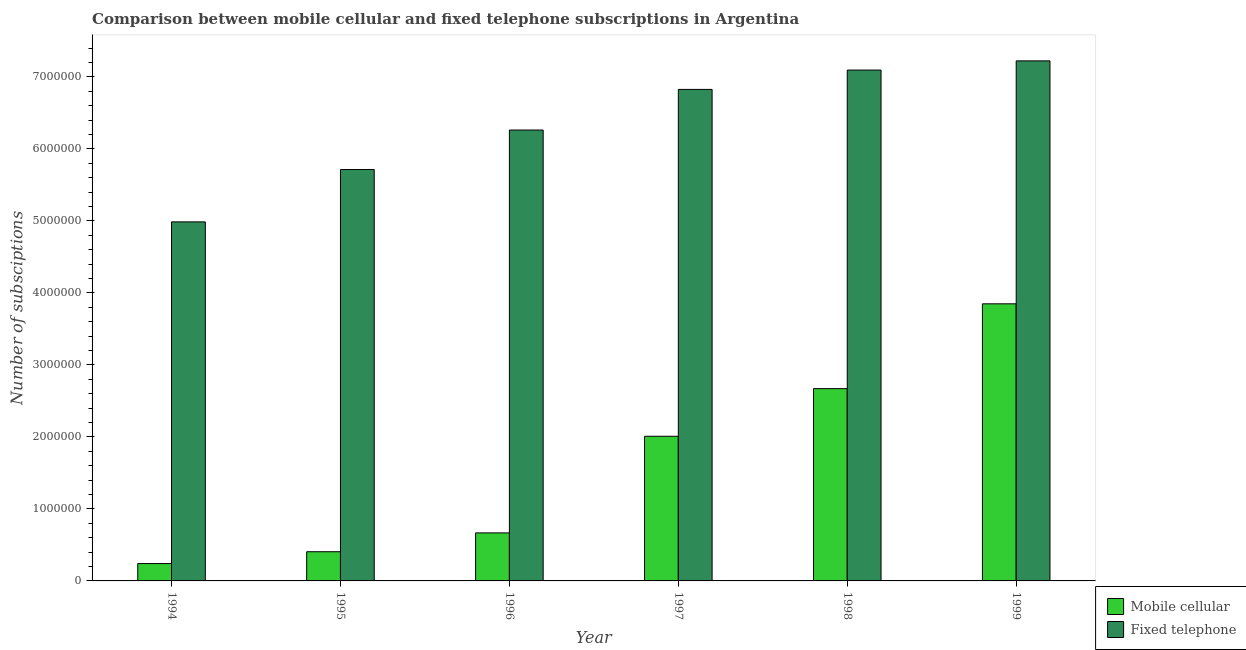How many different coloured bars are there?
Your response must be concise. 2. Are the number of bars per tick equal to the number of legend labels?
Your answer should be very brief. Yes. How many bars are there on the 5th tick from the left?
Offer a very short reply. 2. How many bars are there on the 4th tick from the right?
Your answer should be very brief. 2. In how many cases, is the number of bars for a given year not equal to the number of legend labels?
Your response must be concise. 0. What is the number of fixed telephone subscriptions in 1994?
Your answer should be compact. 4.99e+06. Across all years, what is the maximum number of mobile cellular subscriptions?
Keep it short and to the point. 3.85e+06. Across all years, what is the minimum number of mobile cellular subscriptions?
Keep it short and to the point. 2.41e+05. What is the total number of fixed telephone subscriptions in the graph?
Ensure brevity in your answer.  3.81e+07. What is the difference between the number of mobile cellular subscriptions in 1994 and that in 1999?
Give a very brief answer. -3.61e+06. What is the difference between the number of mobile cellular subscriptions in 1997 and the number of fixed telephone subscriptions in 1998?
Offer a very short reply. -6.62e+05. What is the average number of fixed telephone subscriptions per year?
Offer a terse response. 6.35e+06. In the year 1996, what is the difference between the number of mobile cellular subscriptions and number of fixed telephone subscriptions?
Give a very brief answer. 0. What is the ratio of the number of fixed telephone subscriptions in 1995 to that in 1996?
Offer a very short reply. 0.91. Is the difference between the number of fixed telephone subscriptions in 1995 and 1998 greater than the difference between the number of mobile cellular subscriptions in 1995 and 1998?
Offer a very short reply. No. What is the difference between the highest and the second highest number of fixed telephone subscriptions?
Provide a succinct answer. 1.28e+05. What is the difference between the highest and the lowest number of mobile cellular subscriptions?
Give a very brief answer. 3.61e+06. What does the 1st bar from the left in 1996 represents?
Give a very brief answer. Mobile cellular. What does the 2nd bar from the right in 1995 represents?
Offer a terse response. Mobile cellular. How many years are there in the graph?
Your answer should be compact. 6. Are the values on the major ticks of Y-axis written in scientific E-notation?
Make the answer very short. No. Does the graph contain any zero values?
Provide a short and direct response. No. Where does the legend appear in the graph?
Provide a succinct answer. Bottom right. How many legend labels are there?
Ensure brevity in your answer.  2. What is the title of the graph?
Provide a short and direct response. Comparison between mobile cellular and fixed telephone subscriptions in Argentina. Does "Malaria" appear as one of the legend labels in the graph?
Your answer should be very brief. No. What is the label or title of the Y-axis?
Provide a succinct answer. Number of subsciptions. What is the Number of subsciptions in Mobile cellular in 1994?
Provide a short and direct response. 2.41e+05. What is the Number of subsciptions of Fixed telephone in 1994?
Make the answer very short. 4.99e+06. What is the Number of subsciptions of Mobile cellular in 1995?
Give a very brief answer. 4.05e+05. What is the Number of subsciptions of Fixed telephone in 1995?
Provide a short and direct response. 5.71e+06. What is the Number of subsciptions in Mobile cellular in 1996?
Offer a very short reply. 6.67e+05. What is the Number of subsciptions of Fixed telephone in 1996?
Make the answer very short. 6.26e+06. What is the Number of subsciptions in Mobile cellular in 1997?
Offer a very short reply. 2.01e+06. What is the Number of subsciptions in Fixed telephone in 1997?
Ensure brevity in your answer.  6.83e+06. What is the Number of subsciptions of Mobile cellular in 1998?
Your answer should be compact. 2.67e+06. What is the Number of subsciptions in Fixed telephone in 1998?
Give a very brief answer. 7.10e+06. What is the Number of subsciptions of Mobile cellular in 1999?
Your response must be concise. 3.85e+06. What is the Number of subsciptions in Fixed telephone in 1999?
Provide a succinct answer. 7.22e+06. Across all years, what is the maximum Number of subsciptions of Mobile cellular?
Offer a terse response. 3.85e+06. Across all years, what is the maximum Number of subsciptions in Fixed telephone?
Provide a succinct answer. 7.22e+06. Across all years, what is the minimum Number of subsciptions in Mobile cellular?
Offer a very short reply. 2.41e+05. Across all years, what is the minimum Number of subsciptions in Fixed telephone?
Keep it short and to the point. 4.99e+06. What is the total Number of subsciptions of Mobile cellular in the graph?
Keep it short and to the point. 9.84e+06. What is the total Number of subsciptions in Fixed telephone in the graph?
Provide a short and direct response. 3.81e+07. What is the difference between the Number of subsciptions in Mobile cellular in 1994 and that in 1995?
Keep it short and to the point. -1.64e+05. What is the difference between the Number of subsciptions in Fixed telephone in 1994 and that in 1995?
Provide a succinct answer. -7.27e+05. What is the difference between the Number of subsciptions in Mobile cellular in 1994 and that in 1996?
Provide a succinct answer. -4.26e+05. What is the difference between the Number of subsciptions in Fixed telephone in 1994 and that in 1996?
Your response must be concise. -1.28e+06. What is the difference between the Number of subsciptions of Mobile cellular in 1994 and that in 1997?
Provide a succinct answer. -1.77e+06. What is the difference between the Number of subsciptions of Fixed telephone in 1994 and that in 1997?
Provide a short and direct response. -1.84e+06. What is the difference between the Number of subsciptions of Mobile cellular in 1994 and that in 1998?
Make the answer very short. -2.43e+06. What is the difference between the Number of subsciptions in Fixed telephone in 1994 and that in 1998?
Give a very brief answer. -2.11e+06. What is the difference between the Number of subsciptions of Mobile cellular in 1994 and that in 1999?
Your response must be concise. -3.61e+06. What is the difference between the Number of subsciptions of Fixed telephone in 1994 and that in 1999?
Your answer should be very brief. -2.24e+06. What is the difference between the Number of subsciptions in Mobile cellular in 1995 and that in 1996?
Make the answer very short. -2.62e+05. What is the difference between the Number of subsciptions in Fixed telephone in 1995 and that in 1996?
Provide a succinct answer. -5.48e+05. What is the difference between the Number of subsciptions in Mobile cellular in 1995 and that in 1997?
Provide a short and direct response. -1.60e+06. What is the difference between the Number of subsciptions of Fixed telephone in 1995 and that in 1997?
Provide a short and direct response. -1.11e+06. What is the difference between the Number of subsciptions in Mobile cellular in 1995 and that in 1998?
Your answer should be very brief. -2.27e+06. What is the difference between the Number of subsciptions of Fixed telephone in 1995 and that in 1998?
Ensure brevity in your answer.  -1.38e+06. What is the difference between the Number of subsciptions in Mobile cellular in 1995 and that in 1999?
Your answer should be compact. -3.44e+06. What is the difference between the Number of subsciptions of Fixed telephone in 1995 and that in 1999?
Make the answer very short. -1.51e+06. What is the difference between the Number of subsciptions of Mobile cellular in 1996 and that in 1997?
Provide a short and direct response. -1.34e+06. What is the difference between the Number of subsciptions in Fixed telephone in 1996 and that in 1997?
Offer a terse response. -5.64e+05. What is the difference between the Number of subsciptions of Mobile cellular in 1996 and that in 1998?
Keep it short and to the point. -2.00e+06. What is the difference between the Number of subsciptions of Fixed telephone in 1996 and that in 1998?
Offer a terse response. -8.33e+05. What is the difference between the Number of subsciptions of Mobile cellular in 1996 and that in 1999?
Provide a succinct answer. -3.18e+06. What is the difference between the Number of subsciptions of Fixed telephone in 1996 and that in 1999?
Give a very brief answer. -9.61e+05. What is the difference between the Number of subsciptions of Mobile cellular in 1997 and that in 1998?
Give a very brief answer. -6.62e+05. What is the difference between the Number of subsciptions of Fixed telephone in 1997 and that in 1998?
Give a very brief answer. -2.69e+05. What is the difference between the Number of subsciptions in Mobile cellular in 1997 and that in 1999?
Ensure brevity in your answer.  -1.84e+06. What is the difference between the Number of subsciptions in Fixed telephone in 1997 and that in 1999?
Offer a very short reply. -3.96e+05. What is the difference between the Number of subsciptions of Mobile cellular in 1998 and that in 1999?
Your answer should be compact. -1.18e+06. What is the difference between the Number of subsciptions of Fixed telephone in 1998 and that in 1999?
Provide a succinct answer. -1.28e+05. What is the difference between the Number of subsciptions of Mobile cellular in 1994 and the Number of subsciptions of Fixed telephone in 1995?
Keep it short and to the point. -5.47e+06. What is the difference between the Number of subsciptions of Mobile cellular in 1994 and the Number of subsciptions of Fixed telephone in 1996?
Give a very brief answer. -6.02e+06. What is the difference between the Number of subsciptions of Mobile cellular in 1994 and the Number of subsciptions of Fixed telephone in 1997?
Your answer should be compact. -6.59e+06. What is the difference between the Number of subsciptions in Mobile cellular in 1994 and the Number of subsciptions in Fixed telephone in 1998?
Keep it short and to the point. -6.85e+06. What is the difference between the Number of subsciptions of Mobile cellular in 1994 and the Number of subsciptions of Fixed telephone in 1999?
Ensure brevity in your answer.  -6.98e+06. What is the difference between the Number of subsciptions in Mobile cellular in 1995 and the Number of subsciptions in Fixed telephone in 1996?
Provide a succinct answer. -5.86e+06. What is the difference between the Number of subsciptions in Mobile cellular in 1995 and the Number of subsciptions in Fixed telephone in 1997?
Offer a terse response. -6.42e+06. What is the difference between the Number of subsciptions in Mobile cellular in 1995 and the Number of subsciptions in Fixed telephone in 1998?
Your response must be concise. -6.69e+06. What is the difference between the Number of subsciptions in Mobile cellular in 1995 and the Number of subsciptions in Fixed telephone in 1999?
Ensure brevity in your answer.  -6.82e+06. What is the difference between the Number of subsciptions of Mobile cellular in 1996 and the Number of subsciptions of Fixed telephone in 1997?
Give a very brief answer. -6.16e+06. What is the difference between the Number of subsciptions of Mobile cellular in 1996 and the Number of subsciptions of Fixed telephone in 1998?
Make the answer very short. -6.43e+06. What is the difference between the Number of subsciptions in Mobile cellular in 1996 and the Number of subsciptions in Fixed telephone in 1999?
Your answer should be compact. -6.56e+06. What is the difference between the Number of subsciptions of Mobile cellular in 1997 and the Number of subsciptions of Fixed telephone in 1998?
Give a very brief answer. -5.09e+06. What is the difference between the Number of subsciptions in Mobile cellular in 1997 and the Number of subsciptions in Fixed telephone in 1999?
Offer a very short reply. -5.21e+06. What is the difference between the Number of subsciptions of Mobile cellular in 1998 and the Number of subsciptions of Fixed telephone in 1999?
Keep it short and to the point. -4.55e+06. What is the average Number of subsciptions in Mobile cellular per year?
Your answer should be very brief. 1.64e+06. What is the average Number of subsciptions of Fixed telephone per year?
Make the answer very short. 6.35e+06. In the year 1994, what is the difference between the Number of subsciptions in Mobile cellular and Number of subsciptions in Fixed telephone?
Give a very brief answer. -4.75e+06. In the year 1995, what is the difference between the Number of subsciptions in Mobile cellular and Number of subsciptions in Fixed telephone?
Ensure brevity in your answer.  -5.31e+06. In the year 1996, what is the difference between the Number of subsciptions of Mobile cellular and Number of subsciptions of Fixed telephone?
Provide a short and direct response. -5.60e+06. In the year 1997, what is the difference between the Number of subsciptions of Mobile cellular and Number of subsciptions of Fixed telephone?
Your response must be concise. -4.82e+06. In the year 1998, what is the difference between the Number of subsciptions of Mobile cellular and Number of subsciptions of Fixed telephone?
Offer a terse response. -4.42e+06. In the year 1999, what is the difference between the Number of subsciptions in Mobile cellular and Number of subsciptions in Fixed telephone?
Your response must be concise. -3.37e+06. What is the ratio of the Number of subsciptions in Mobile cellular in 1994 to that in 1995?
Keep it short and to the point. 0.59. What is the ratio of the Number of subsciptions of Fixed telephone in 1994 to that in 1995?
Your response must be concise. 0.87. What is the ratio of the Number of subsciptions in Mobile cellular in 1994 to that in 1996?
Make the answer very short. 0.36. What is the ratio of the Number of subsciptions of Fixed telephone in 1994 to that in 1996?
Your answer should be compact. 0.8. What is the ratio of the Number of subsciptions of Mobile cellular in 1994 to that in 1997?
Make the answer very short. 0.12. What is the ratio of the Number of subsciptions in Fixed telephone in 1994 to that in 1997?
Keep it short and to the point. 0.73. What is the ratio of the Number of subsciptions of Mobile cellular in 1994 to that in 1998?
Provide a succinct answer. 0.09. What is the ratio of the Number of subsciptions of Fixed telephone in 1994 to that in 1998?
Keep it short and to the point. 0.7. What is the ratio of the Number of subsciptions in Mobile cellular in 1994 to that in 1999?
Give a very brief answer. 0.06. What is the ratio of the Number of subsciptions in Fixed telephone in 1994 to that in 1999?
Ensure brevity in your answer.  0.69. What is the ratio of the Number of subsciptions in Mobile cellular in 1995 to that in 1996?
Keep it short and to the point. 0.61. What is the ratio of the Number of subsciptions of Fixed telephone in 1995 to that in 1996?
Your answer should be very brief. 0.91. What is the ratio of the Number of subsciptions of Mobile cellular in 1995 to that in 1997?
Your answer should be compact. 0.2. What is the ratio of the Number of subsciptions in Fixed telephone in 1995 to that in 1997?
Provide a succinct answer. 0.84. What is the ratio of the Number of subsciptions in Mobile cellular in 1995 to that in 1998?
Ensure brevity in your answer.  0.15. What is the ratio of the Number of subsciptions of Fixed telephone in 1995 to that in 1998?
Your response must be concise. 0.81. What is the ratio of the Number of subsciptions of Mobile cellular in 1995 to that in 1999?
Offer a very short reply. 0.11. What is the ratio of the Number of subsciptions in Fixed telephone in 1995 to that in 1999?
Your answer should be very brief. 0.79. What is the ratio of the Number of subsciptions in Mobile cellular in 1996 to that in 1997?
Provide a succinct answer. 0.33. What is the ratio of the Number of subsciptions in Fixed telephone in 1996 to that in 1997?
Give a very brief answer. 0.92. What is the ratio of the Number of subsciptions in Mobile cellular in 1996 to that in 1998?
Give a very brief answer. 0.25. What is the ratio of the Number of subsciptions of Fixed telephone in 1996 to that in 1998?
Your response must be concise. 0.88. What is the ratio of the Number of subsciptions of Mobile cellular in 1996 to that in 1999?
Offer a very short reply. 0.17. What is the ratio of the Number of subsciptions of Fixed telephone in 1996 to that in 1999?
Your response must be concise. 0.87. What is the ratio of the Number of subsciptions of Mobile cellular in 1997 to that in 1998?
Keep it short and to the point. 0.75. What is the ratio of the Number of subsciptions of Fixed telephone in 1997 to that in 1998?
Keep it short and to the point. 0.96. What is the ratio of the Number of subsciptions of Mobile cellular in 1997 to that in 1999?
Offer a very short reply. 0.52. What is the ratio of the Number of subsciptions in Fixed telephone in 1997 to that in 1999?
Your answer should be very brief. 0.95. What is the ratio of the Number of subsciptions of Mobile cellular in 1998 to that in 1999?
Offer a very short reply. 0.69. What is the ratio of the Number of subsciptions in Fixed telephone in 1998 to that in 1999?
Provide a short and direct response. 0.98. What is the difference between the highest and the second highest Number of subsciptions in Mobile cellular?
Offer a very short reply. 1.18e+06. What is the difference between the highest and the second highest Number of subsciptions of Fixed telephone?
Offer a very short reply. 1.28e+05. What is the difference between the highest and the lowest Number of subsciptions of Mobile cellular?
Provide a short and direct response. 3.61e+06. What is the difference between the highest and the lowest Number of subsciptions of Fixed telephone?
Keep it short and to the point. 2.24e+06. 